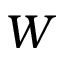Convert formula to latex. <formula><loc_0><loc_0><loc_500><loc_500>W</formula> 